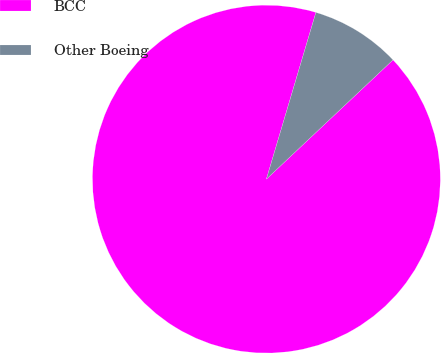Convert chart to OTSL. <chart><loc_0><loc_0><loc_500><loc_500><pie_chart><fcel>BCC<fcel>Other Boeing<nl><fcel>91.62%<fcel>8.38%<nl></chart> 